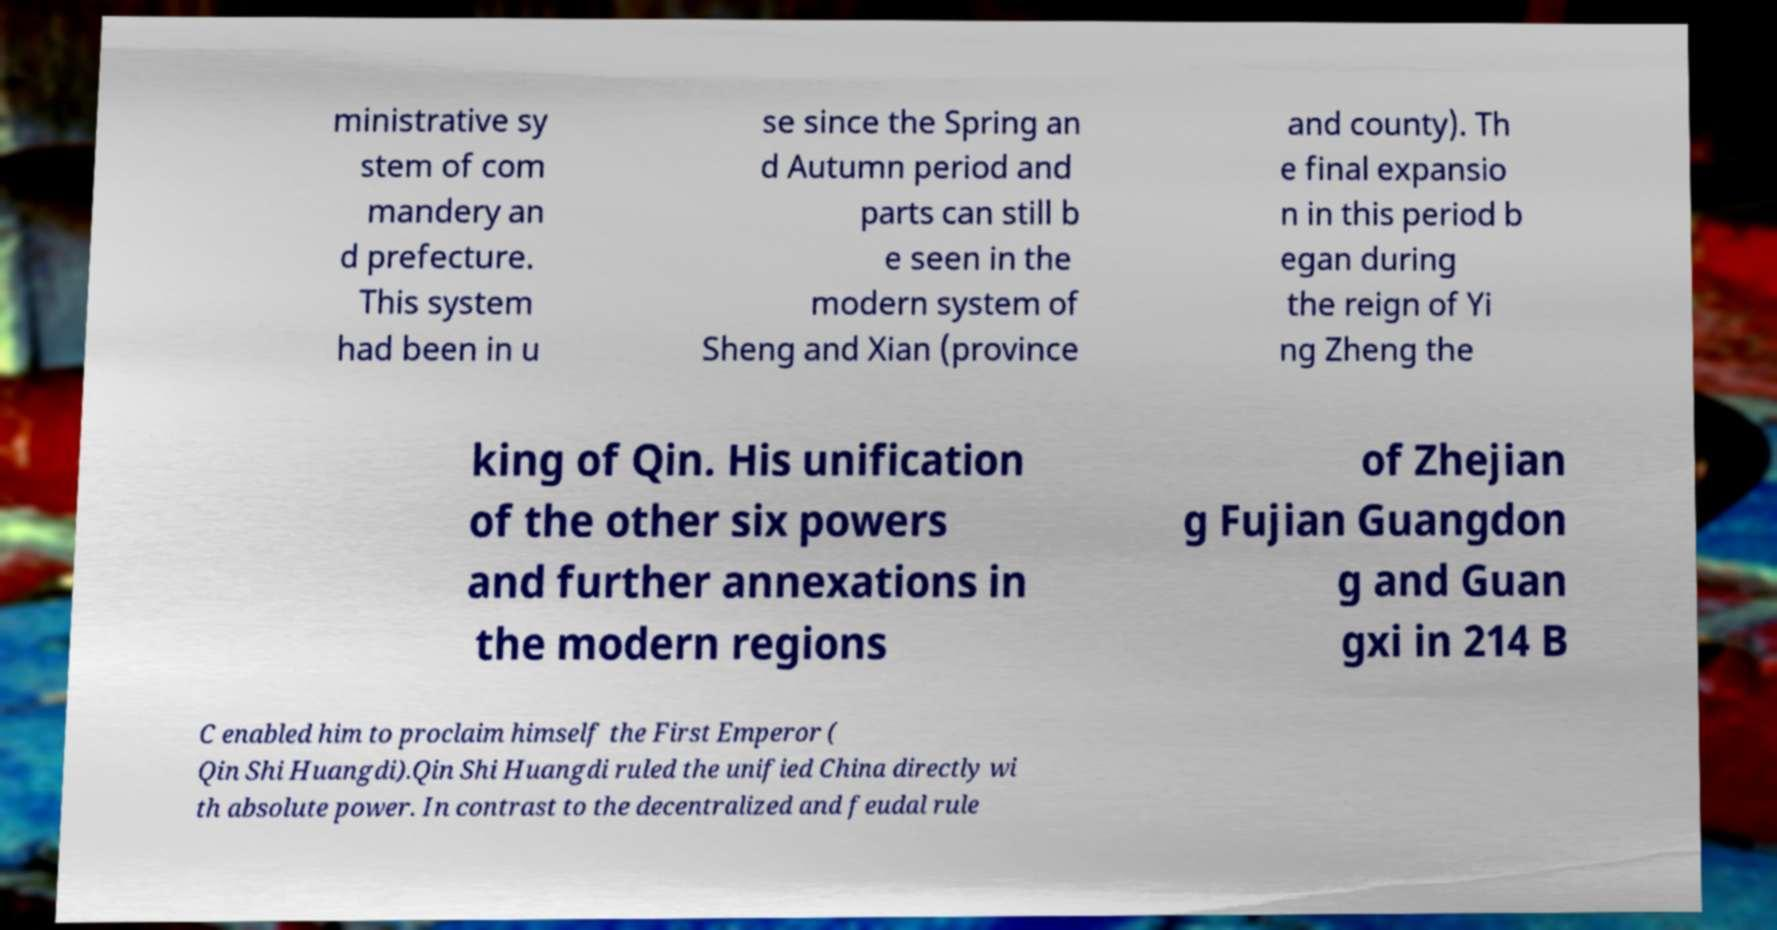Can you read and provide the text displayed in the image?This photo seems to have some interesting text. Can you extract and type it out for me? ministrative sy stem of com mandery an d prefecture. This system had been in u se since the Spring an d Autumn period and parts can still b e seen in the modern system of Sheng and Xian (province and county). Th e final expansio n in this period b egan during the reign of Yi ng Zheng the king of Qin. His unification of the other six powers and further annexations in the modern regions of Zhejian g Fujian Guangdon g and Guan gxi in 214 B C enabled him to proclaim himself the First Emperor ( Qin Shi Huangdi).Qin Shi Huangdi ruled the unified China directly wi th absolute power. In contrast to the decentralized and feudal rule 